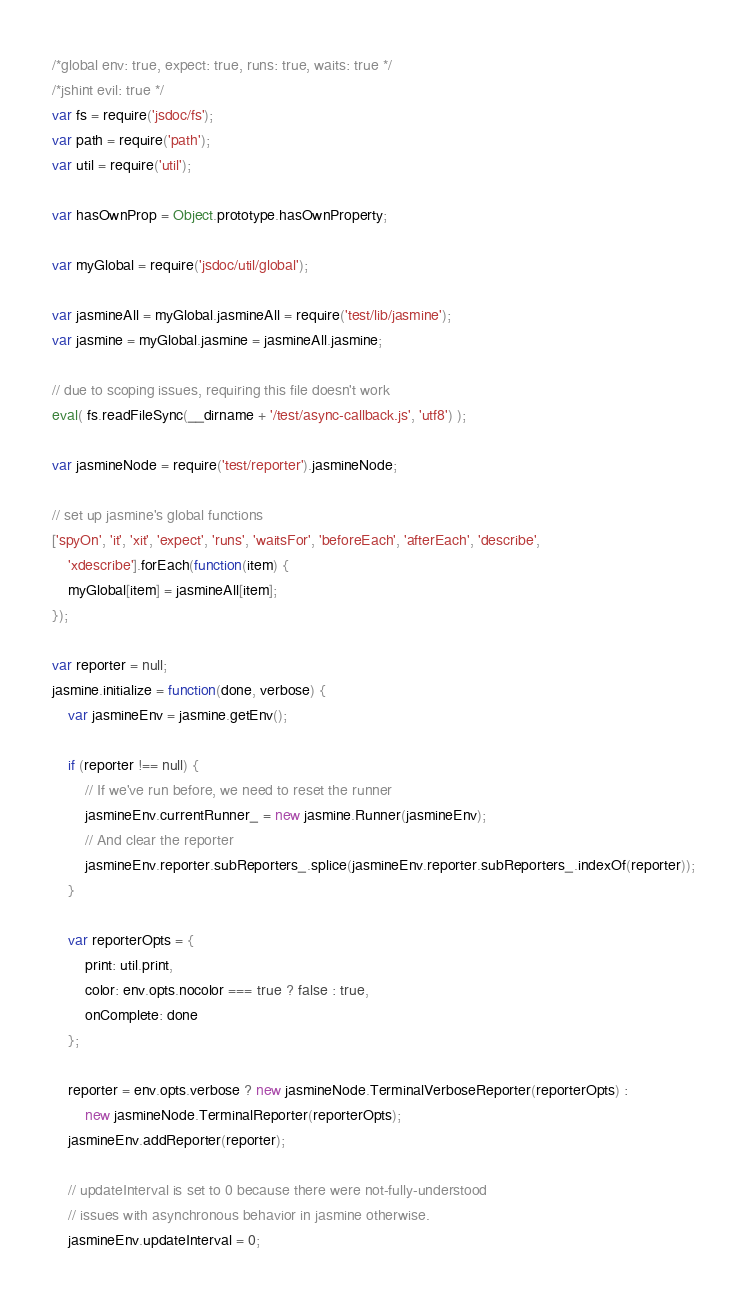Convert code to text. <code><loc_0><loc_0><loc_500><loc_500><_JavaScript_>/*global env: true, expect: true, runs: true, waits: true */
/*jshint evil: true */
var fs = require('jsdoc/fs');
var path = require('path');
var util = require('util');

var hasOwnProp = Object.prototype.hasOwnProperty;

var myGlobal = require('jsdoc/util/global');

var jasmineAll = myGlobal.jasmineAll = require('test/lib/jasmine');
var jasmine = myGlobal.jasmine = jasmineAll.jasmine;

// due to scoping issues, requiring this file doesn't work
eval( fs.readFileSync(__dirname + '/test/async-callback.js', 'utf8') );

var jasmineNode = require('test/reporter').jasmineNode;

// set up jasmine's global functions
['spyOn', 'it', 'xit', 'expect', 'runs', 'waitsFor', 'beforeEach', 'afterEach', 'describe',
    'xdescribe'].forEach(function(item) {
    myGlobal[item] = jasmineAll[item];
});

var reporter = null;
jasmine.initialize = function(done, verbose) {
    var jasmineEnv = jasmine.getEnv();

    if (reporter !== null) {
        // If we've run before, we need to reset the runner
        jasmineEnv.currentRunner_ = new jasmine.Runner(jasmineEnv);
        // And clear the reporter
        jasmineEnv.reporter.subReporters_.splice(jasmineEnv.reporter.subReporters_.indexOf(reporter));
    }

    var reporterOpts = {
        print: util.print,
        color: env.opts.nocolor === true ? false : true,
        onComplete: done
    };

    reporter = env.opts.verbose ? new jasmineNode.TerminalVerboseReporter(reporterOpts) :
        new jasmineNode.TerminalReporter(reporterOpts);
    jasmineEnv.addReporter(reporter);

    // updateInterval is set to 0 because there were not-fully-understood
    // issues with asynchronous behavior in jasmine otherwise.
    jasmineEnv.updateInterval = 0;
</code> 